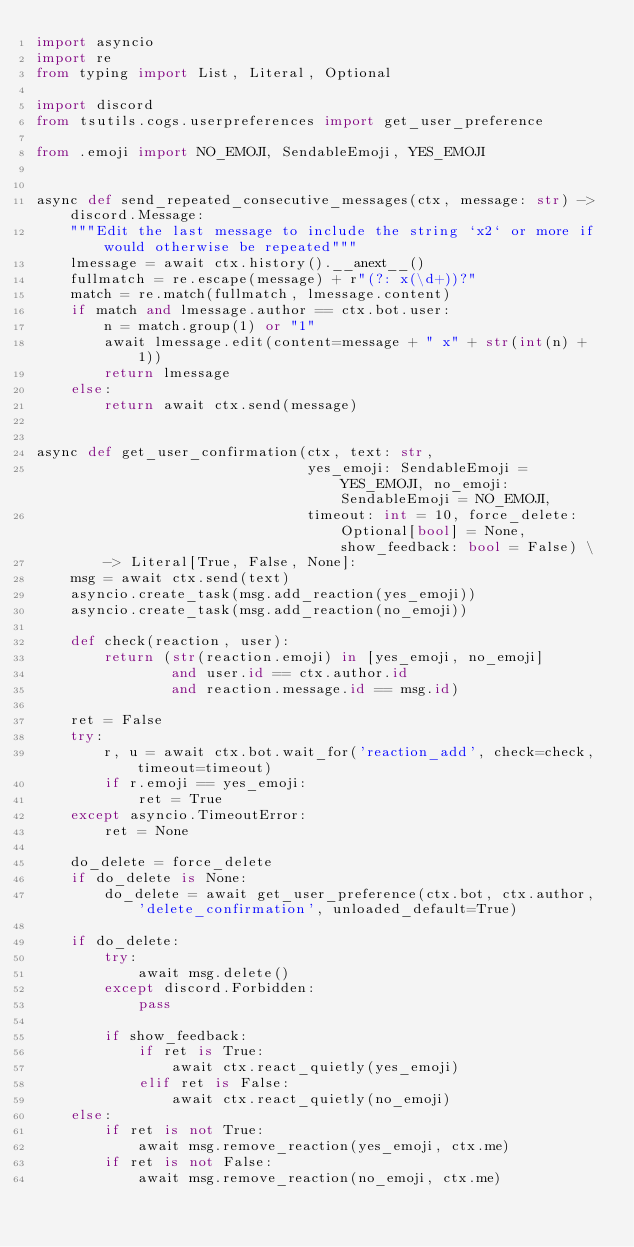<code> <loc_0><loc_0><loc_500><loc_500><_Python_>import asyncio
import re
from typing import List, Literal, Optional

import discord
from tsutils.cogs.userpreferences import get_user_preference

from .emoji import NO_EMOJI, SendableEmoji, YES_EMOJI


async def send_repeated_consecutive_messages(ctx, message: str) -> discord.Message:
    """Edit the last message to include the string `x2` or more if would otherwise be repeated"""
    lmessage = await ctx.history().__anext__()
    fullmatch = re.escape(message) + r"(?: x(\d+))?"
    match = re.match(fullmatch, lmessage.content)
    if match and lmessage.author == ctx.bot.user:
        n = match.group(1) or "1"
        await lmessage.edit(content=message + " x" + str(int(n) + 1))
        return lmessage
    else:
        return await ctx.send(message)


async def get_user_confirmation(ctx, text: str,
                                yes_emoji: SendableEmoji = YES_EMOJI, no_emoji: SendableEmoji = NO_EMOJI,
                                timeout: int = 10, force_delete: Optional[bool] = None, show_feedback: bool = False) \
        -> Literal[True, False, None]:
    msg = await ctx.send(text)
    asyncio.create_task(msg.add_reaction(yes_emoji))
    asyncio.create_task(msg.add_reaction(no_emoji))

    def check(reaction, user):
        return (str(reaction.emoji) in [yes_emoji, no_emoji]
                and user.id == ctx.author.id
                and reaction.message.id == msg.id)

    ret = False
    try:
        r, u = await ctx.bot.wait_for('reaction_add', check=check, timeout=timeout)
        if r.emoji == yes_emoji:
            ret = True
    except asyncio.TimeoutError:
        ret = None

    do_delete = force_delete
    if do_delete is None:
        do_delete = await get_user_preference(ctx.bot, ctx.author, 'delete_confirmation', unloaded_default=True)

    if do_delete:
        try:
            await msg.delete()
        except discord.Forbidden:
            pass

        if show_feedback:
            if ret is True:
                await ctx.react_quietly(yes_emoji)
            elif ret is False:
                await ctx.react_quietly(no_emoji)
    else:
        if ret is not True:
            await msg.remove_reaction(yes_emoji, ctx.me)
        if ret is not False:
            await msg.remove_reaction(no_emoji, ctx.me)
</code> 